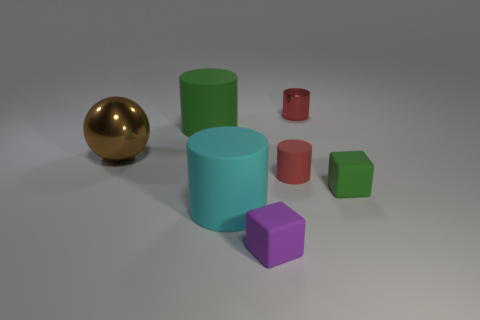Add 1 green matte blocks. How many objects exist? 8 Subtract all balls. How many objects are left? 6 Add 4 tiny cubes. How many tiny cubes are left? 6 Add 7 tiny matte cylinders. How many tiny matte cylinders exist? 8 Subtract 0 blue spheres. How many objects are left? 7 Subtract all metal spheres. Subtract all tiny green things. How many objects are left? 5 